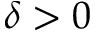<formula> <loc_0><loc_0><loc_500><loc_500>\delta > 0</formula> 